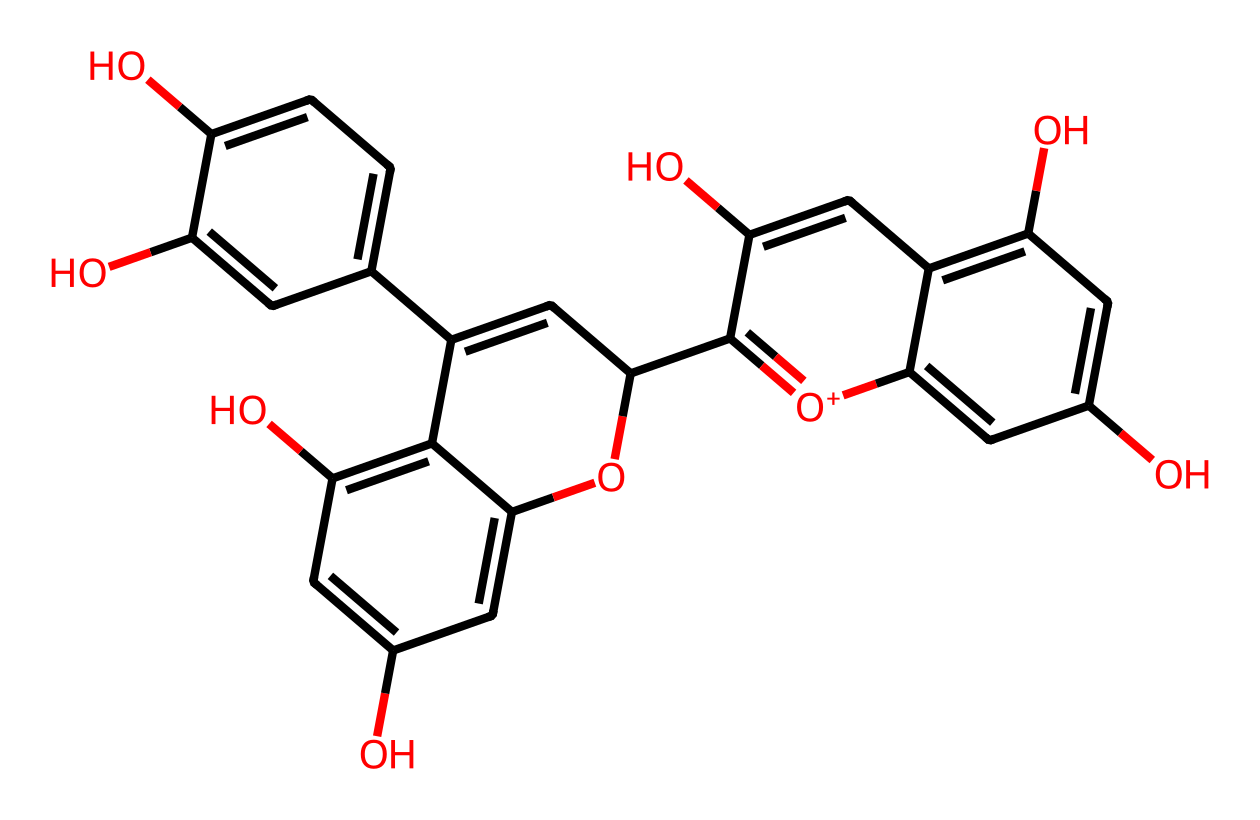What is the name of this chemical? The SMILES representation indicates that this compound is a type of anthocyanin, which are pigments known for their red, purple, and blue colors in fruits and vegetables.
Answer: anthocyanin How many carbon atoms are present in the structure? By analyzing the structure in the SMILES notation, we count all the carbon atoms represented. After careful count, we find a total of 23 carbon atoms in the entire structure.
Answer: 23 How many hydroxyl (–OH) groups are present in this chemical? From the structure, we notice the presence of hydroxyl groups as indicated by the "O" in the SMILES string. Counting these indicates that there are 4 –OH groups in total.
Answer: 4 What type of compound is this? Since this chemical contains aromatic rings and functional groups typical of dyes, it falls under the category of natural pigments, specifically being a flavonoid.
Answer: flavonoid Which part of the chemical indicates its color properties? The numerous hydroxyl groups present on the aromatic rings contribute to its ability to absorb light in various wavelengths, thus giving it the distinguishing red, purple, and blue colors.
Answer: hydroxyl groups What role do the methoxy groups play in this chemical? Methoxy groups (when present) typically affect the color stability and solubility of dyes, enhancing their coloration properties within fruits and vegetables.
Answer: color stability 